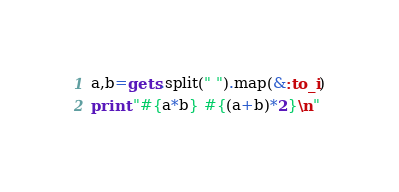Convert code to text. <code><loc_0><loc_0><loc_500><loc_500><_Ruby_>a,b=gets.split(" ").map(&:to_i)
print "#{a*b} #{(a+b)*2}\n"</code> 